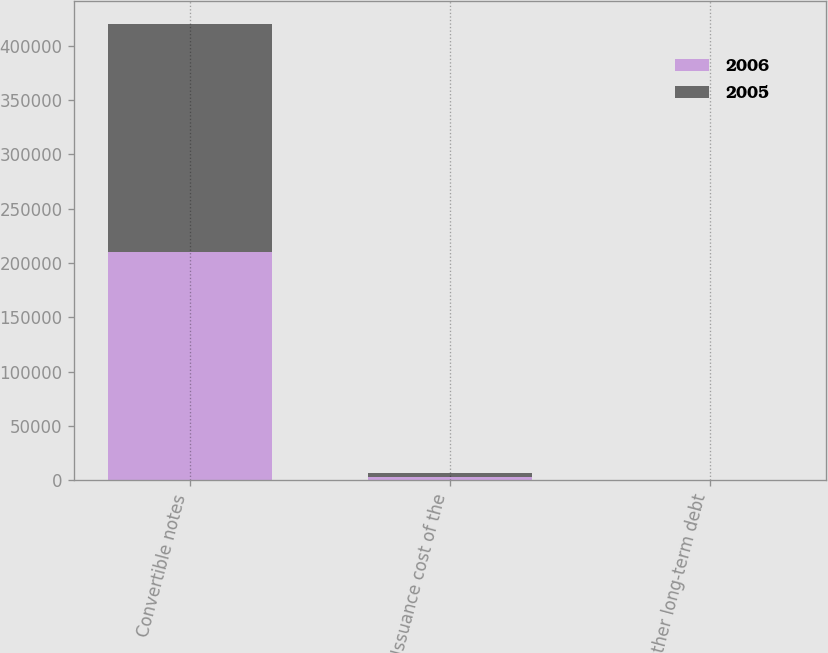Convert chart to OTSL. <chart><loc_0><loc_0><loc_500><loc_500><stacked_bar_chart><ecel><fcel>Convertible notes<fcel>Issuance cost of the<fcel>Other long-term debt<nl><fcel>2006<fcel>210000<fcel>2993<fcel>17<nl><fcel>2005<fcel>210000<fcel>3869<fcel>24<nl></chart> 